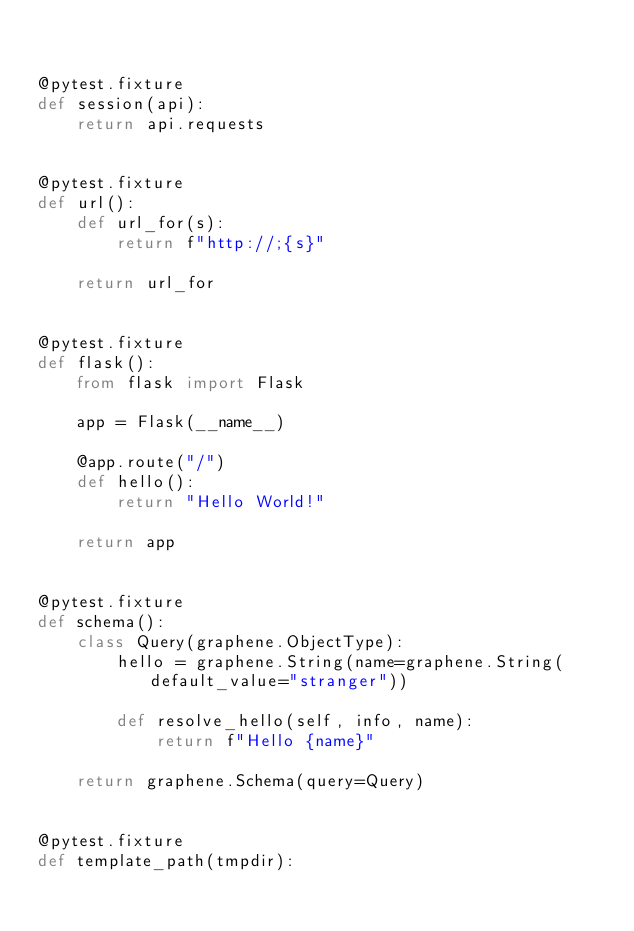Convert code to text. <code><loc_0><loc_0><loc_500><loc_500><_Python_>

@pytest.fixture
def session(api):
    return api.requests


@pytest.fixture
def url():
    def url_for(s):
        return f"http://;{s}"

    return url_for


@pytest.fixture
def flask():
    from flask import Flask

    app = Flask(__name__)

    @app.route("/")
    def hello():
        return "Hello World!"

    return app


@pytest.fixture
def schema():
    class Query(graphene.ObjectType):
        hello = graphene.String(name=graphene.String(default_value="stranger"))

        def resolve_hello(self, info, name):
            return f"Hello {name}"

    return graphene.Schema(query=Query)


@pytest.fixture
def template_path(tmpdir):</code> 